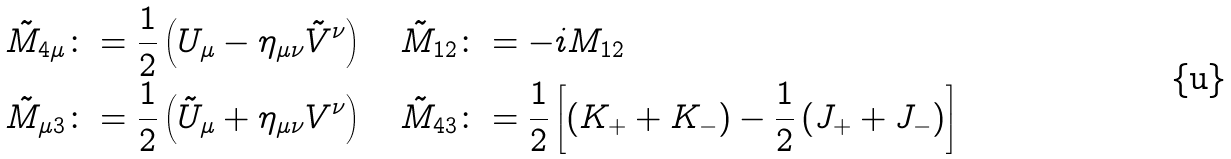Convert formula to latex. <formula><loc_0><loc_0><loc_500><loc_500>\tilde { M } _ { 4 \mu } & \colon = \frac { 1 } { 2 } \left ( U _ { \mu } - \eta _ { \mu \nu } \tilde { V } ^ { \nu } \right ) \quad \tilde { M } _ { 1 2 } \colon = - i M _ { 1 2 } \\ \tilde { M } _ { \mu 3 } & \colon = \frac { 1 } { 2 } \left ( \tilde { U } _ { \mu } + \eta _ { \mu \nu } V ^ { \nu } \right ) \quad \tilde { M } _ { 4 3 } \colon = \frac { 1 } { 2 } \left [ \left ( K _ { + } + K _ { - } \right ) - \frac { 1 } { 2 } \left ( J _ { + } + J _ { - } \right ) \right ]</formula> 